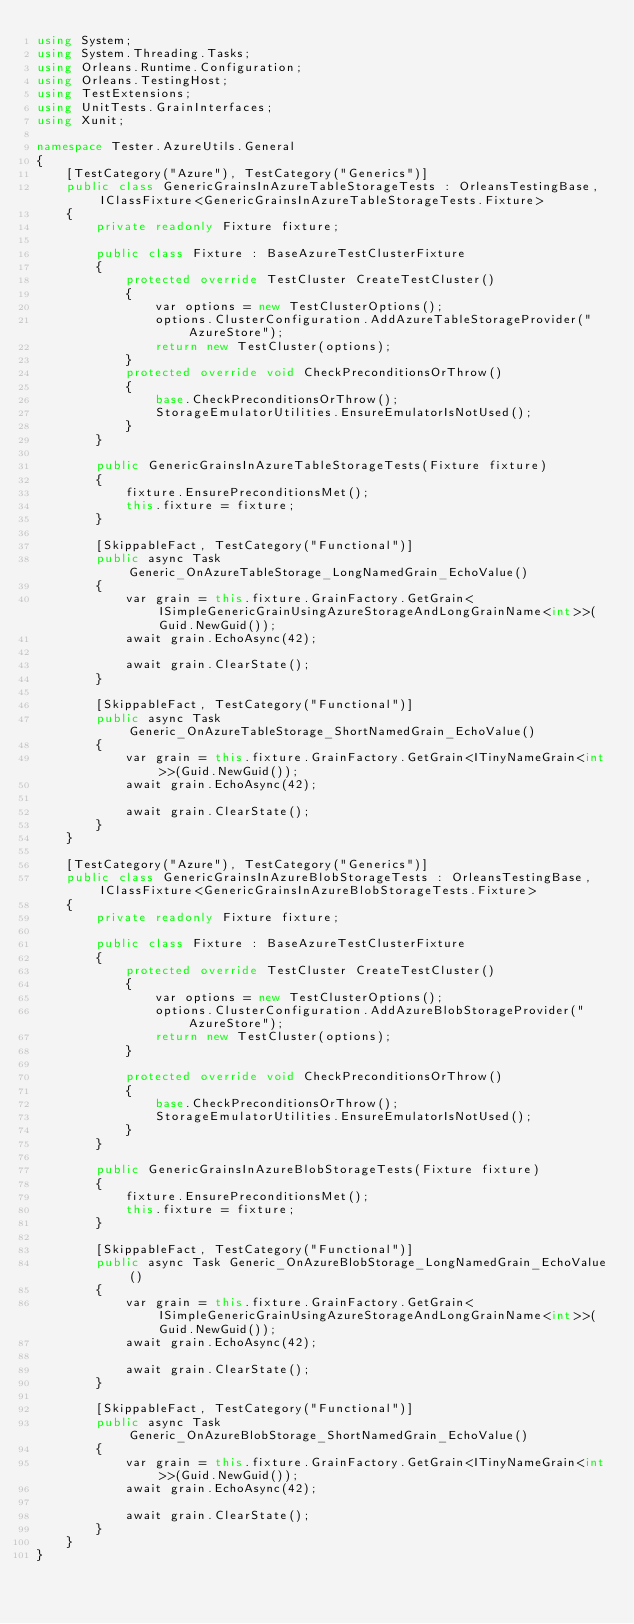Convert code to text. <code><loc_0><loc_0><loc_500><loc_500><_C#_>using System;
using System.Threading.Tasks;
using Orleans.Runtime.Configuration;
using Orleans.TestingHost;
using TestExtensions;
using UnitTests.GrainInterfaces;
using Xunit;

namespace Tester.AzureUtils.General
{
    [TestCategory("Azure"), TestCategory("Generics")]
    public class GenericGrainsInAzureTableStorageTests : OrleansTestingBase, IClassFixture<GenericGrainsInAzureTableStorageTests.Fixture>
    {
        private readonly Fixture fixture;

        public class Fixture : BaseAzureTestClusterFixture
        {
            protected override TestCluster CreateTestCluster()
            {
                var options = new TestClusterOptions();
                options.ClusterConfiguration.AddAzureTableStorageProvider("AzureStore");
                return new TestCluster(options);
            }
            protected override void CheckPreconditionsOrThrow()
            {
                base.CheckPreconditionsOrThrow();
                StorageEmulatorUtilities.EnsureEmulatorIsNotUsed();
            }
        }

        public GenericGrainsInAzureTableStorageTests(Fixture fixture)
        {
            fixture.EnsurePreconditionsMet();
            this.fixture = fixture;
        }

        [SkippableFact, TestCategory("Functional")]
        public async Task Generic_OnAzureTableStorage_LongNamedGrain_EchoValue()
        {
            var grain = this.fixture.GrainFactory.GetGrain<ISimpleGenericGrainUsingAzureStorageAndLongGrainName<int>>(Guid.NewGuid());
            await grain.EchoAsync(42);

            await grain.ClearState();
        }

        [SkippableFact, TestCategory("Functional")]
        public async Task Generic_OnAzureTableStorage_ShortNamedGrain_EchoValue()
        {
            var grain = this.fixture.GrainFactory.GetGrain<ITinyNameGrain<int>>(Guid.NewGuid());
            await grain.EchoAsync(42);

            await grain.ClearState();
        }
    }

    [TestCategory("Azure"), TestCategory("Generics")]
    public class GenericGrainsInAzureBlobStorageTests : OrleansTestingBase, IClassFixture<GenericGrainsInAzureBlobStorageTests.Fixture>
    {
        private readonly Fixture fixture;

        public class Fixture : BaseAzureTestClusterFixture
        {
            protected override TestCluster CreateTestCluster()
            {
                var options = new TestClusterOptions();
                options.ClusterConfiguration.AddAzureBlobStorageProvider("AzureStore");
                return new TestCluster(options);
            }

            protected override void CheckPreconditionsOrThrow()
            {
                base.CheckPreconditionsOrThrow();
                StorageEmulatorUtilities.EnsureEmulatorIsNotUsed();
            }
        }

        public GenericGrainsInAzureBlobStorageTests(Fixture fixture)
        {
            fixture.EnsurePreconditionsMet();
            this.fixture = fixture;
        }

        [SkippableFact, TestCategory("Functional")]
        public async Task Generic_OnAzureBlobStorage_LongNamedGrain_EchoValue()
        {
            var grain = this.fixture.GrainFactory.GetGrain<ISimpleGenericGrainUsingAzureStorageAndLongGrainName<int>>(Guid.NewGuid());
            await grain.EchoAsync(42);

            await grain.ClearState();
        }

        [SkippableFact, TestCategory("Functional")]
        public async Task Generic_OnAzureBlobStorage_ShortNamedGrain_EchoValue()
        {
            var grain = this.fixture.GrainFactory.GetGrain<ITinyNameGrain<int>>(Guid.NewGuid());
            await grain.EchoAsync(42);

            await grain.ClearState();
        }
    }
}
</code> 